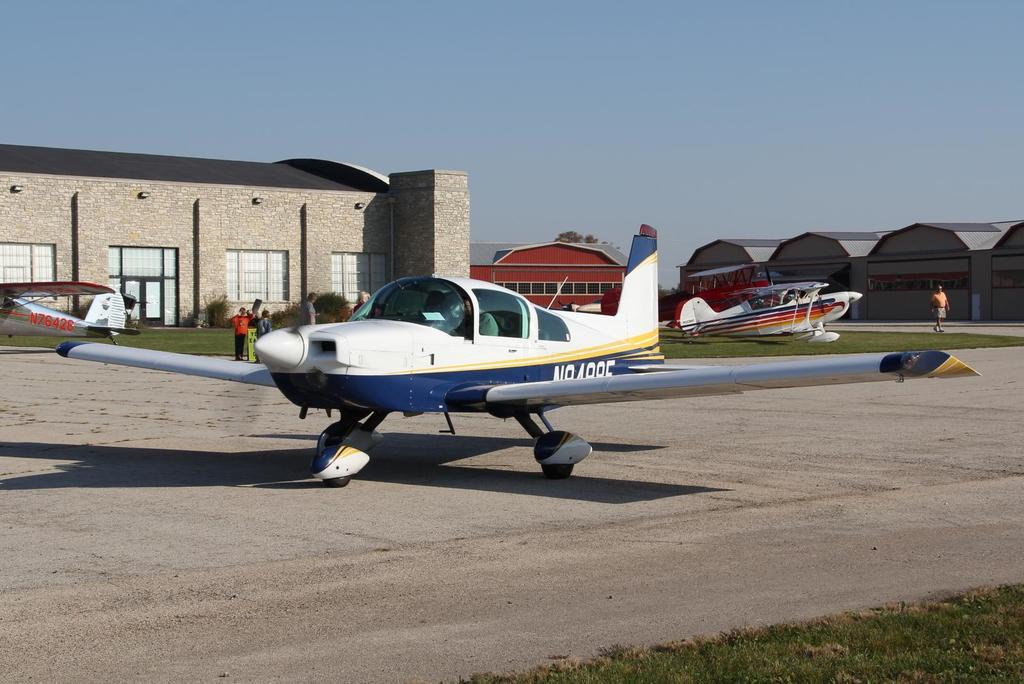<image>
Present a compact description of the photo's key features. Silver N76426 plane sits in the background while another white and blue plane sits on the runway. 